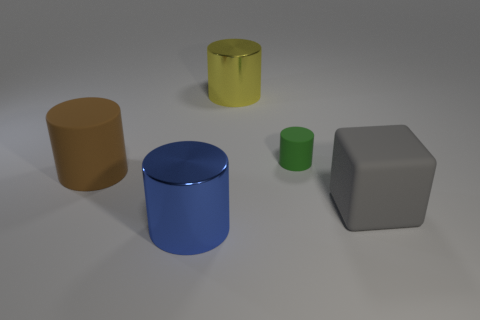Can you describe the lighting in the scene? The lighting in the scene is diffuse and soft, with the shadows being soft-edged and not very dark, suggesting an overcast lighting situation or the presence of multiple light sources.  Are there any shadows that indicate the direction of the light source? Yes, the shadows cast by the objects fall predominantly to the right, indicating that the primary light source is to the left of the objects in the image. 